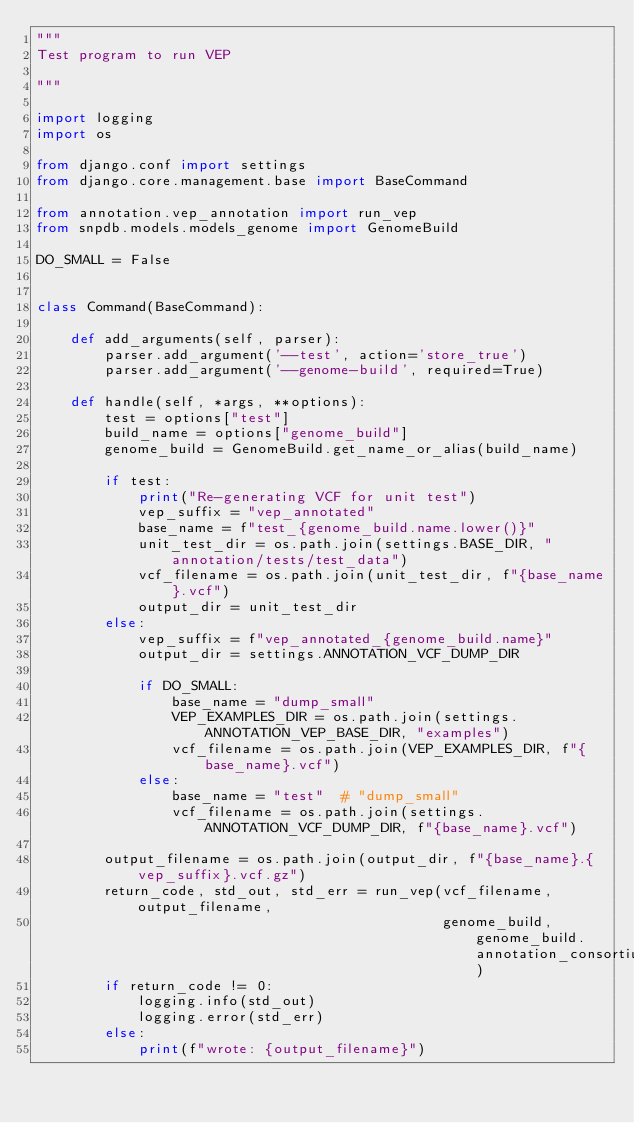<code> <loc_0><loc_0><loc_500><loc_500><_Python_>"""
Test program to run VEP

"""

import logging
import os

from django.conf import settings
from django.core.management.base import BaseCommand

from annotation.vep_annotation import run_vep
from snpdb.models.models_genome import GenomeBuild

DO_SMALL = False


class Command(BaseCommand):

    def add_arguments(self, parser):
        parser.add_argument('--test', action='store_true')
        parser.add_argument('--genome-build', required=True)

    def handle(self, *args, **options):
        test = options["test"]
        build_name = options["genome_build"]
        genome_build = GenomeBuild.get_name_or_alias(build_name)

        if test:
            print("Re-generating VCF for unit test")
            vep_suffix = "vep_annotated"
            base_name = f"test_{genome_build.name.lower()}"
            unit_test_dir = os.path.join(settings.BASE_DIR, "annotation/tests/test_data")
            vcf_filename = os.path.join(unit_test_dir, f"{base_name}.vcf")
            output_dir = unit_test_dir
        else:
            vep_suffix = f"vep_annotated_{genome_build.name}"
            output_dir = settings.ANNOTATION_VCF_DUMP_DIR

            if DO_SMALL:
                base_name = "dump_small"
                VEP_EXAMPLES_DIR = os.path.join(settings.ANNOTATION_VEP_BASE_DIR, "examples")
                vcf_filename = os.path.join(VEP_EXAMPLES_DIR, f"{base_name}.vcf")
            else:
                base_name = "test"  # "dump_small"
                vcf_filename = os.path.join(settings.ANNOTATION_VCF_DUMP_DIR, f"{base_name}.vcf")

        output_filename = os.path.join(output_dir, f"{base_name}.{vep_suffix}.vcf.gz")
        return_code, std_out, std_err = run_vep(vcf_filename, output_filename,
                                                genome_build, genome_build.annotation_consortium)
        if return_code != 0:
            logging.info(std_out)
            logging.error(std_err)
        else:
            print(f"wrote: {output_filename}")
</code> 